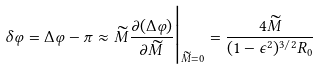Convert formula to latex. <formula><loc_0><loc_0><loc_500><loc_500>\delta \varphi = \Delta \varphi - \pi \approx \widetilde { M } \frac { \partial ( \Delta \varphi ) } { \partial \widetilde { M } } \Big | _ { \widetilde { M } = 0 } = \frac { 4 \widetilde { M } } { ( 1 - \epsilon ^ { 2 } ) ^ { 3 / 2 } R _ { 0 } }</formula> 